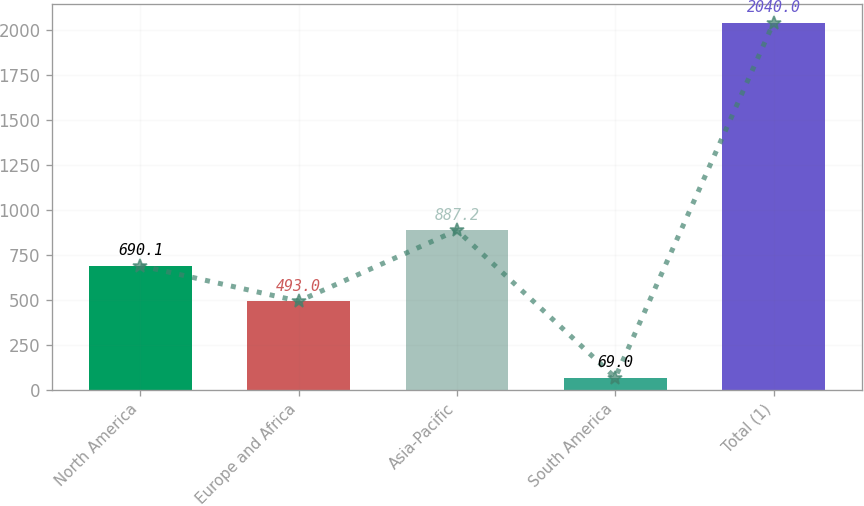Convert chart. <chart><loc_0><loc_0><loc_500><loc_500><bar_chart><fcel>North America<fcel>Europe and Africa<fcel>Asia-Pacific<fcel>South America<fcel>Total (1)<nl><fcel>690.1<fcel>493<fcel>887.2<fcel>69<fcel>2040<nl></chart> 